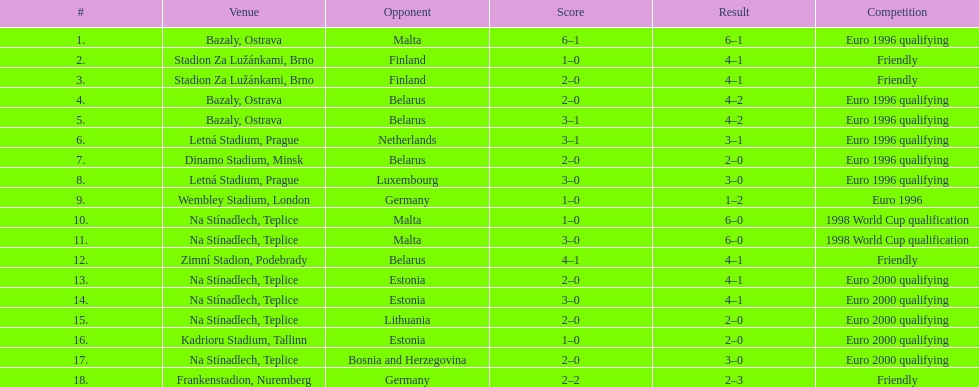Bazaly, ostrava was used on 6 september 1004, but what venue was used on 18 september 1996? Na Stínadlech, Teplice. Parse the full table. {'header': ['#', 'Venue', 'Opponent', 'Score', 'Result', 'Competition'], 'rows': [['1.', 'Bazaly, Ostrava', 'Malta', '6–1', '6–1', 'Euro 1996 qualifying'], ['2.', 'Stadion Za Lužánkami, Brno', 'Finland', '1–0', '4–1', 'Friendly'], ['3.', 'Stadion Za Lužánkami, Brno', 'Finland', '2–0', '4–1', 'Friendly'], ['4.', 'Bazaly, Ostrava', 'Belarus', '2–0', '4–2', 'Euro 1996 qualifying'], ['5.', 'Bazaly, Ostrava', 'Belarus', '3–1', '4–2', 'Euro 1996 qualifying'], ['6.', 'Letná Stadium, Prague', 'Netherlands', '3–1', '3–1', 'Euro 1996 qualifying'], ['7.', 'Dinamo Stadium, Minsk', 'Belarus', '2–0', '2–0', 'Euro 1996 qualifying'], ['8.', 'Letná Stadium, Prague', 'Luxembourg', '3–0', '3–0', 'Euro 1996 qualifying'], ['9.', 'Wembley Stadium, London', 'Germany', '1–0', '1–2', 'Euro 1996'], ['10.', 'Na Stínadlech, Teplice', 'Malta', '1–0', '6–0', '1998 World Cup qualification'], ['11.', 'Na Stínadlech, Teplice', 'Malta', '3–0', '6–0', '1998 World Cup qualification'], ['12.', 'Zimní Stadion, Podebrady', 'Belarus', '4–1', '4–1', 'Friendly'], ['13.', 'Na Stínadlech, Teplice', 'Estonia', '2–0', '4–1', 'Euro 2000 qualifying'], ['14.', 'Na Stínadlech, Teplice', 'Estonia', '3–0', '4–1', 'Euro 2000 qualifying'], ['15.', 'Na Stínadlech, Teplice', 'Lithuania', '2–0', '2–0', 'Euro 2000 qualifying'], ['16.', 'Kadrioru Stadium, Tallinn', 'Estonia', '1–0', '2–0', 'Euro 2000 qualifying'], ['17.', 'Na Stínadlech, Teplice', 'Bosnia and Herzegovina', '2–0', '3–0', 'Euro 2000 qualifying'], ['18.', 'Frankenstadion, Nuremberg', 'Germany', '2–2', '2–3', 'Friendly']]} 